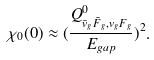Convert formula to latex. <formula><loc_0><loc_0><loc_500><loc_500>\chi _ { 0 } ( 0 ) \approx ( \frac { Q _ { \bar { v } _ { g } \bar { F } _ { g } , v _ { g } F _ { g } } ^ { 0 } } { E _ { g a p } } ) ^ { 2 } .</formula> 